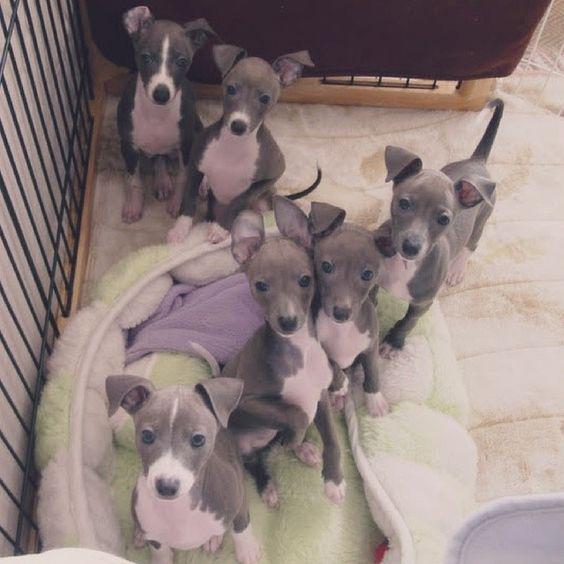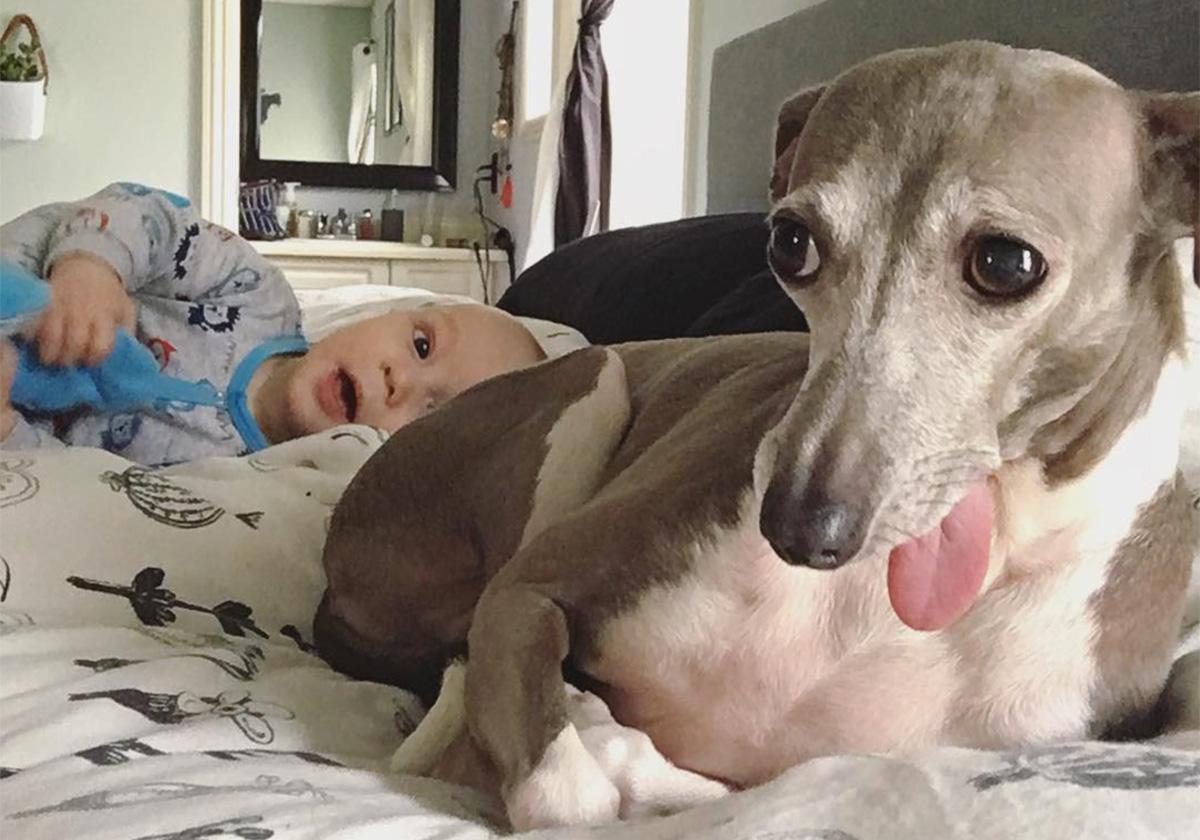The first image is the image on the left, the second image is the image on the right. Analyze the images presented: Is the assertion "None of the dogs are wearing collars." valid? Answer yes or no. Yes. The first image is the image on the left, the second image is the image on the right. Examine the images to the left and right. Is the description "There are at least four gray and white puppies." accurate? Answer yes or no. Yes. 